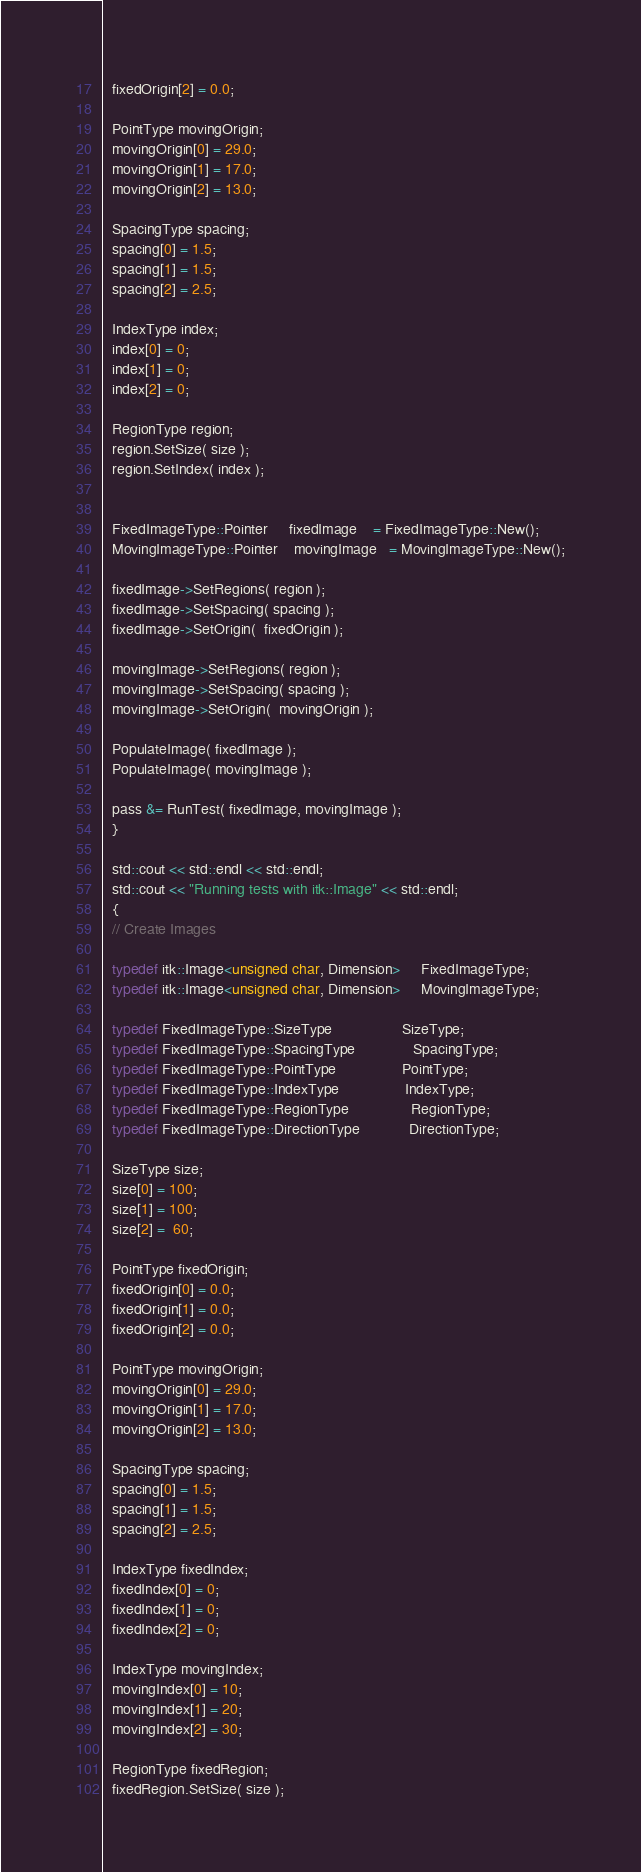Convert code to text. <code><loc_0><loc_0><loc_500><loc_500><_C++_>  fixedOrigin[2] = 0.0;

  PointType movingOrigin;
  movingOrigin[0] = 29.0;
  movingOrigin[1] = 17.0;
  movingOrigin[2] = 13.0;

  SpacingType spacing;
  spacing[0] = 1.5;
  spacing[1] = 1.5;
  spacing[2] = 2.5;

  IndexType index;
  index[0] = 0;
  index[1] = 0;
  index[2] = 0;

  RegionType region;
  region.SetSize( size );
  region.SetIndex( index );


  FixedImageType::Pointer     fixedImage    = FixedImageType::New();
  MovingImageType::Pointer    movingImage   = MovingImageType::New();

  fixedImage->SetRegions( region );
  fixedImage->SetSpacing( spacing );
  fixedImage->SetOrigin(  fixedOrigin );

  movingImage->SetRegions( region );
  movingImage->SetSpacing( spacing );
  movingImage->SetOrigin(  movingOrigin );

  PopulateImage( fixedImage );
  PopulateImage( movingImage );

  pass &= RunTest( fixedImage, movingImage );
  }

  std::cout << std::endl << std::endl;
  std::cout << "Running tests with itk::Image" << std::endl;
  {
  // Create Images

  typedef itk::Image<unsigned char, Dimension>     FixedImageType;
  typedef itk::Image<unsigned char, Dimension>     MovingImageType;

  typedef FixedImageType::SizeType                 SizeType;
  typedef FixedImageType::SpacingType              SpacingType;
  typedef FixedImageType::PointType                PointType;
  typedef FixedImageType::IndexType                IndexType;
  typedef FixedImageType::RegionType               RegionType;
  typedef FixedImageType::DirectionType            DirectionType;

  SizeType size;
  size[0] = 100;
  size[1] = 100;
  size[2] =  60;

  PointType fixedOrigin;
  fixedOrigin[0] = 0.0;
  fixedOrigin[1] = 0.0;
  fixedOrigin[2] = 0.0;

  PointType movingOrigin;
  movingOrigin[0] = 29.0;
  movingOrigin[1] = 17.0;
  movingOrigin[2] = 13.0;

  SpacingType spacing;
  spacing[0] = 1.5;
  spacing[1] = 1.5;
  spacing[2] = 2.5;

  IndexType fixedIndex;
  fixedIndex[0] = 0;
  fixedIndex[1] = 0;
  fixedIndex[2] = 0;

  IndexType movingIndex;
  movingIndex[0] = 10;
  movingIndex[1] = 20;
  movingIndex[2] = 30;

  RegionType fixedRegion;
  fixedRegion.SetSize( size );</code> 